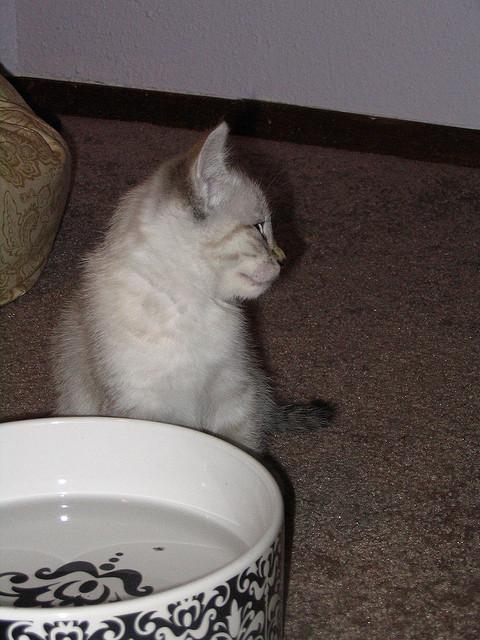What color is the cat?
Concise answer only. White. How many bowls are pictured?
Short answer required. 1. What is cast?
Keep it brief. Shadow. Does the kitten want the water?
Keep it brief. No. What is inside of the bowl?
Be succinct. Water. 